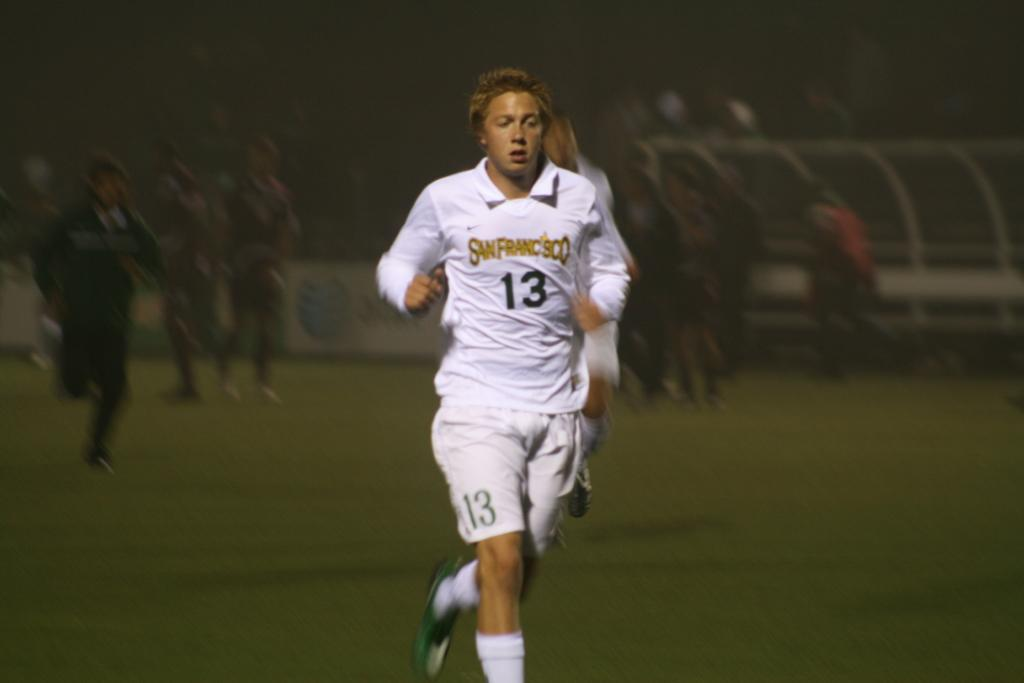Provide a one-sentence caption for the provided image. A runner wearing a San Fransisco shirt with the number 13 on it. 